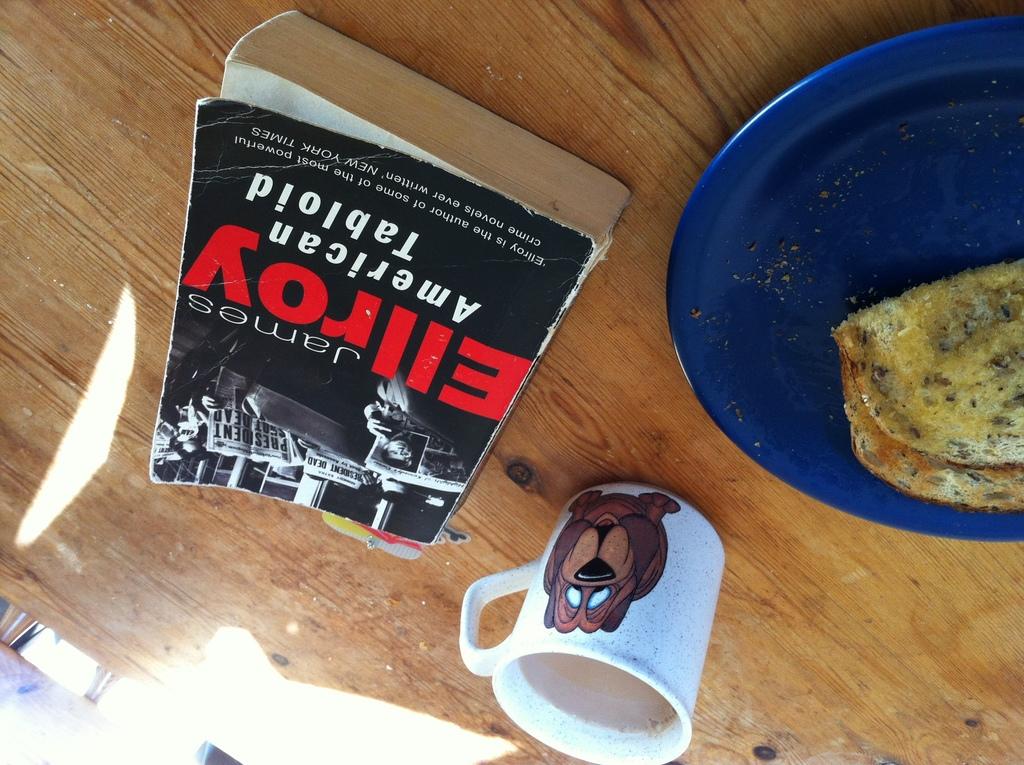What is the name of the book next to the mug?
Keep it short and to the point. American tabloid. What do the res letters say?
Your response must be concise. Ellroy. 